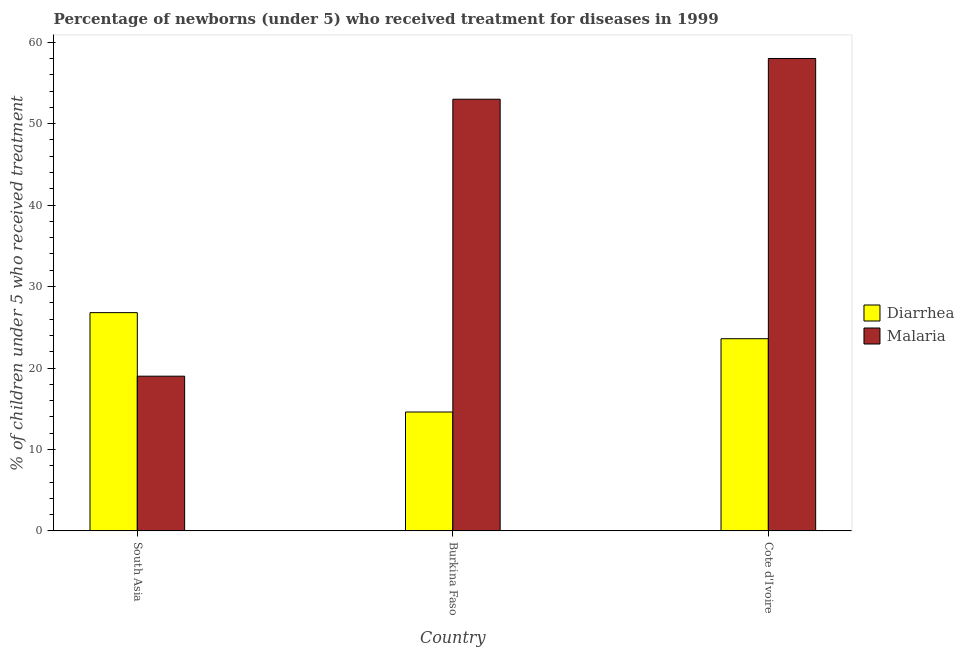How many groups of bars are there?
Your response must be concise. 3. How many bars are there on the 2nd tick from the left?
Your answer should be compact. 2. How many bars are there on the 3rd tick from the right?
Your answer should be very brief. 2. What is the label of the 2nd group of bars from the left?
Keep it short and to the point. Burkina Faso. In how many cases, is the number of bars for a given country not equal to the number of legend labels?
Offer a terse response. 0. What is the percentage of children who received treatment for diarrhoea in South Asia?
Provide a succinct answer. 26.8. Across all countries, what is the maximum percentage of children who received treatment for malaria?
Keep it short and to the point. 58. Across all countries, what is the minimum percentage of children who received treatment for malaria?
Offer a very short reply. 19. In which country was the percentage of children who received treatment for diarrhoea minimum?
Make the answer very short. Burkina Faso. What is the total percentage of children who received treatment for diarrhoea in the graph?
Make the answer very short. 65. What is the difference between the percentage of children who received treatment for malaria in Burkina Faso and that in South Asia?
Keep it short and to the point. 34. What is the difference between the percentage of children who received treatment for malaria in Burkina Faso and the percentage of children who received treatment for diarrhoea in South Asia?
Make the answer very short. 26.2. What is the average percentage of children who received treatment for malaria per country?
Provide a succinct answer. 43.33. What is the difference between the percentage of children who received treatment for diarrhoea and percentage of children who received treatment for malaria in Cote d'Ivoire?
Your answer should be very brief. -34.4. What is the ratio of the percentage of children who received treatment for malaria in Burkina Faso to that in South Asia?
Your answer should be compact. 2.79. What is the difference between the highest and the second highest percentage of children who received treatment for diarrhoea?
Make the answer very short. 3.2. What is the difference between the highest and the lowest percentage of children who received treatment for malaria?
Your response must be concise. 39. Is the sum of the percentage of children who received treatment for diarrhoea in Burkina Faso and South Asia greater than the maximum percentage of children who received treatment for malaria across all countries?
Your response must be concise. No. What does the 2nd bar from the left in Burkina Faso represents?
Provide a succinct answer. Malaria. What does the 1st bar from the right in South Asia represents?
Ensure brevity in your answer.  Malaria. How many bars are there?
Keep it short and to the point. 6. How many countries are there in the graph?
Give a very brief answer. 3. Does the graph contain any zero values?
Give a very brief answer. No. What is the title of the graph?
Your response must be concise. Percentage of newborns (under 5) who received treatment for diseases in 1999. What is the label or title of the X-axis?
Offer a terse response. Country. What is the label or title of the Y-axis?
Keep it short and to the point. % of children under 5 who received treatment. What is the % of children under 5 who received treatment in Diarrhea in South Asia?
Your response must be concise. 26.8. What is the % of children under 5 who received treatment of Malaria in Burkina Faso?
Your answer should be compact. 53. What is the % of children under 5 who received treatment of Diarrhea in Cote d'Ivoire?
Provide a short and direct response. 23.6. What is the % of children under 5 who received treatment in Malaria in Cote d'Ivoire?
Your response must be concise. 58. Across all countries, what is the maximum % of children under 5 who received treatment in Diarrhea?
Offer a terse response. 26.8. Across all countries, what is the maximum % of children under 5 who received treatment in Malaria?
Your response must be concise. 58. Across all countries, what is the minimum % of children under 5 who received treatment in Diarrhea?
Your answer should be compact. 14.6. Across all countries, what is the minimum % of children under 5 who received treatment in Malaria?
Provide a succinct answer. 19. What is the total % of children under 5 who received treatment of Diarrhea in the graph?
Your response must be concise. 65. What is the total % of children under 5 who received treatment in Malaria in the graph?
Your response must be concise. 130. What is the difference between the % of children under 5 who received treatment in Diarrhea in South Asia and that in Burkina Faso?
Offer a terse response. 12.2. What is the difference between the % of children under 5 who received treatment in Malaria in South Asia and that in Burkina Faso?
Keep it short and to the point. -34. What is the difference between the % of children under 5 who received treatment in Diarrhea in South Asia and that in Cote d'Ivoire?
Your answer should be compact. 3.2. What is the difference between the % of children under 5 who received treatment in Malaria in South Asia and that in Cote d'Ivoire?
Your response must be concise. -39. What is the difference between the % of children under 5 who received treatment in Diarrhea in Burkina Faso and that in Cote d'Ivoire?
Provide a short and direct response. -9. What is the difference between the % of children under 5 who received treatment in Malaria in Burkina Faso and that in Cote d'Ivoire?
Keep it short and to the point. -5. What is the difference between the % of children under 5 who received treatment in Diarrhea in South Asia and the % of children under 5 who received treatment in Malaria in Burkina Faso?
Offer a terse response. -26.2. What is the difference between the % of children under 5 who received treatment of Diarrhea in South Asia and the % of children under 5 who received treatment of Malaria in Cote d'Ivoire?
Keep it short and to the point. -31.2. What is the difference between the % of children under 5 who received treatment of Diarrhea in Burkina Faso and the % of children under 5 who received treatment of Malaria in Cote d'Ivoire?
Your answer should be compact. -43.4. What is the average % of children under 5 who received treatment of Diarrhea per country?
Your answer should be very brief. 21.67. What is the average % of children under 5 who received treatment of Malaria per country?
Your response must be concise. 43.33. What is the difference between the % of children under 5 who received treatment of Diarrhea and % of children under 5 who received treatment of Malaria in Burkina Faso?
Your answer should be very brief. -38.4. What is the difference between the % of children under 5 who received treatment of Diarrhea and % of children under 5 who received treatment of Malaria in Cote d'Ivoire?
Your answer should be compact. -34.4. What is the ratio of the % of children under 5 who received treatment in Diarrhea in South Asia to that in Burkina Faso?
Your response must be concise. 1.84. What is the ratio of the % of children under 5 who received treatment in Malaria in South Asia to that in Burkina Faso?
Offer a very short reply. 0.36. What is the ratio of the % of children under 5 who received treatment of Diarrhea in South Asia to that in Cote d'Ivoire?
Provide a short and direct response. 1.14. What is the ratio of the % of children under 5 who received treatment in Malaria in South Asia to that in Cote d'Ivoire?
Provide a short and direct response. 0.33. What is the ratio of the % of children under 5 who received treatment of Diarrhea in Burkina Faso to that in Cote d'Ivoire?
Keep it short and to the point. 0.62. What is the ratio of the % of children under 5 who received treatment in Malaria in Burkina Faso to that in Cote d'Ivoire?
Provide a short and direct response. 0.91. What is the difference between the highest and the second highest % of children under 5 who received treatment of Malaria?
Provide a short and direct response. 5. What is the difference between the highest and the lowest % of children under 5 who received treatment in Malaria?
Keep it short and to the point. 39. 